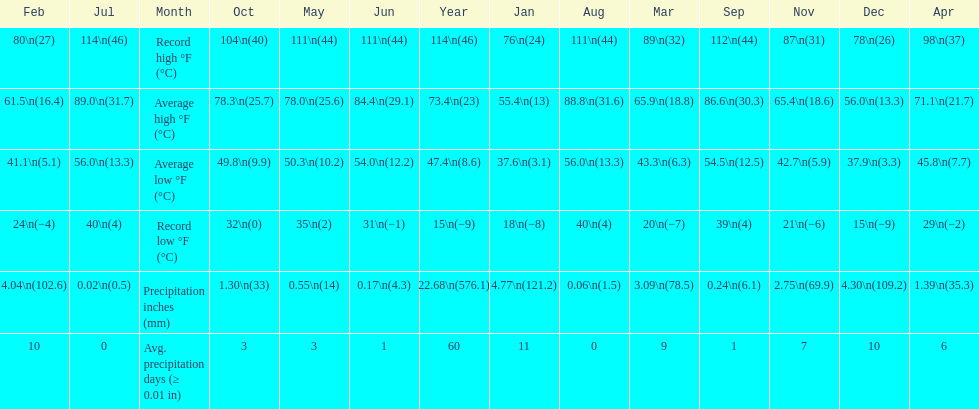How many months how a record low below 25 degrees? 6. 